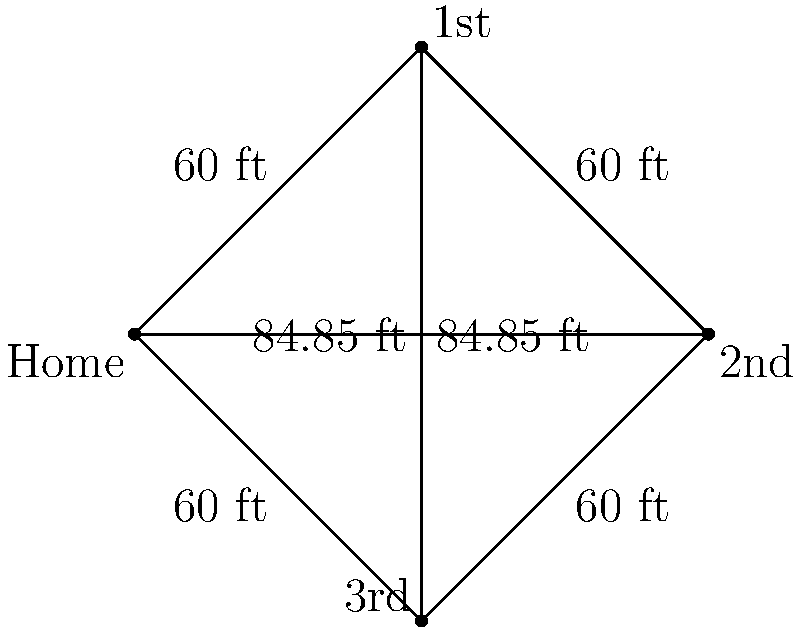In a Little League baseball diamond, if the distance between each base is 60 feet, what is the distance from home plate to second base (in feet)? To find the distance from home plate to second base, we need to follow these steps:

1. Recognize that the baseball diamond forms a square, with each side measuring 60 feet.

2. The line from home plate to second base forms the diagonal of this square.

3. To calculate the length of the diagonal, we can use the Pythagorean theorem:
   $a^2 + b^2 = c^2$, where $c$ is the diagonal we're looking for.

4. In this case, $a$ and $b$ are both 60 feet (the length of one side of the square).

5. Let's plug these values into the formula:
   $60^2 + 60^2 = c^2$

6. Simplify:
   $3600 + 3600 = c^2$
   $7200 = c^2$

7. Take the square root of both sides:
   $\sqrt{7200} = c$

8. Simplify:
   $c = 60\sqrt{2} \approx 84.85$ feet

Therefore, the distance from home plate to second base is $60\sqrt{2}$ feet, or approximately 84.85 feet.
Answer: $60\sqrt{2}$ feet (or approximately 84.85 feet) 